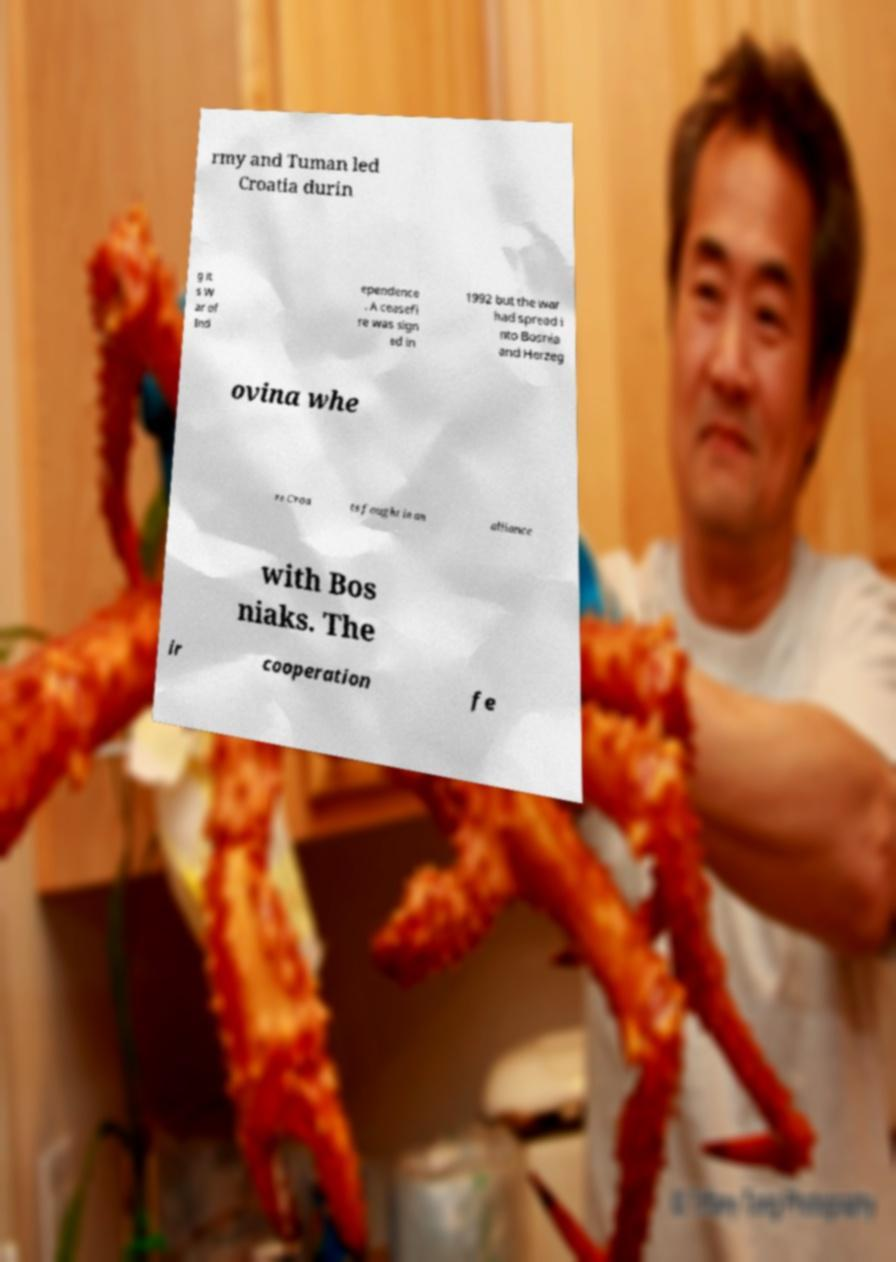Please read and relay the text visible in this image. What does it say? rmy and Tuman led Croatia durin g it s W ar of Ind ependence . A ceasefi re was sign ed in 1992 but the war had spread i nto Bosnia and Herzeg ovina whe re Croa ts fought in an alliance with Bos niaks. The ir cooperation fe 